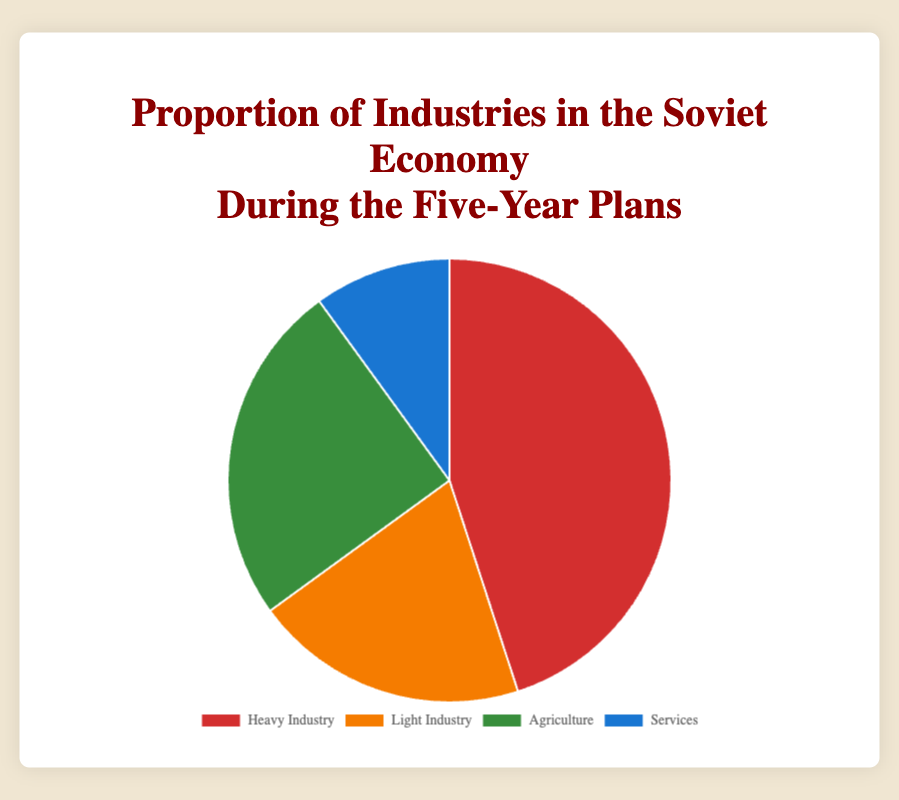What proportion of the Soviet economy was taken up by Heavy Industry? The chart shows that the proportion of Heavy Industry in the Soviet economy is 45%.
Answer: 45% Which industry had the smallest proportion in the Soviet economy? Observing the pie chart, Services had the smallest proportion at 10%.
Answer: Services What is the combined proportion of Light Industry and Agriculture? Light Industry has a proportion of 20%, and Agriculture has 25%. Adding these gives 20% + 25% = 45%.
Answer: 45% Which two industries together make up exactly half of the Soviet economy? Heavy Industry makes up 45%, and Services make up 10%. Summing these proportions gives 45% + 10% = 55%, which is more than half. Now, Light Industry is 20% and Agriculture is 25%, summing these proportions, we get 20% + 25% = 45%. Thus, no two industries combined make exactly half the economy.
Answer: None Which industries had a greater proportion than Services? By looking at the pie chart, Heavy Industry (45%), Light Industry (20%), and Agriculture (25%) each had a larger proportion compared to Services, which had 10%.
Answer: Heavy Industry, Light Industry, Agriculture What is the color representing Agriculture in the pie chart? The sector for Agriculture is represented in green as per the color scheme shown.
Answer: Green How much larger is the proportion of Heavy Industry compared to Services? The proportion of Heavy Industry is 45%, and Services is 10%. The difference is 45% - 10% = 35%.
Answer: 35% If you combine the proportions of Light Industry and Services, how does it compare to Agriculture? Light Industry is 20%, and Services is 10%. Their combined proportion is 20% + 10% = 30%. Agriculture's proportion is 25%, so 30% is larger than 25%.
Answer: 30% is larger than 25% What proportion of the Soviet economy did non-Heavy Industries account for? Non-Heavy Industries include Light Industry (20%), Agriculture (25%), and Services (10%). Adding these proportions gives 20% + 25% + 10% = 55%.
Answer: 55% Which segment of the pie chart is the largest? Heavy Industry, represented by the largest pie segment, accounts for 45% of the Soviet economy.
Answer: Heavy Industry 